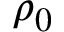<formula> <loc_0><loc_0><loc_500><loc_500>\rho _ { 0 }</formula> 